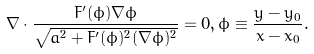<formula> <loc_0><loc_0><loc_500><loc_500>\nabla \cdot \frac { F ^ { \prime } ( \phi ) \nabla \phi } { \sqrt { a ^ { 2 } + F ^ { \prime } ( \phi ) ^ { 2 } ( \nabla \phi ) ^ { 2 } } } = 0 , \phi \equiv \frac { y - y _ { 0 } } { x - x _ { 0 } } .</formula> 